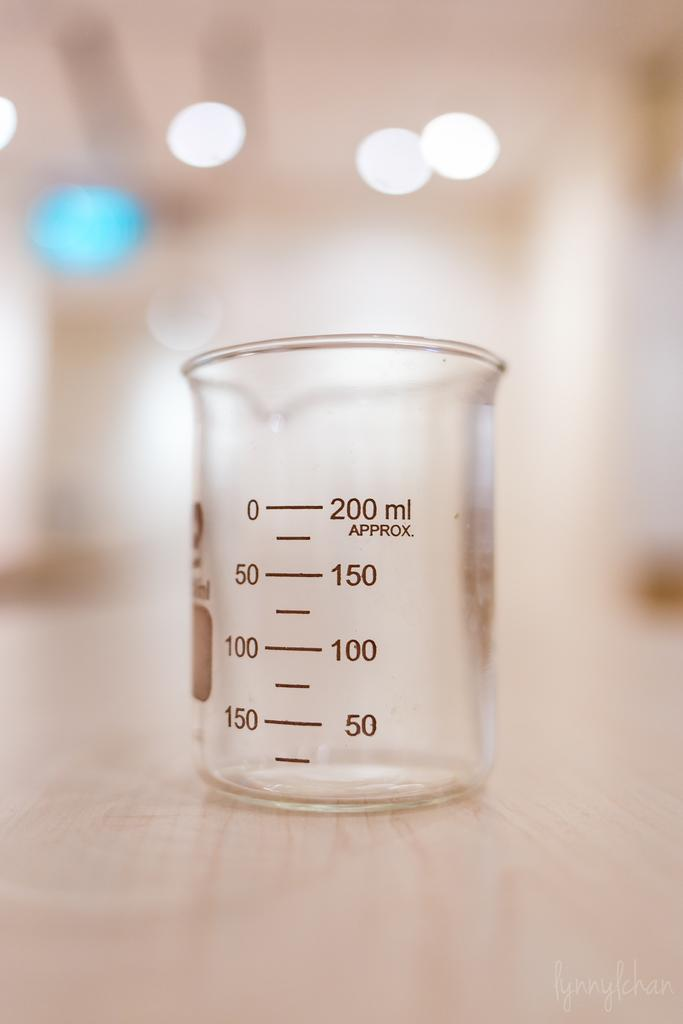<image>
Summarize the visual content of the image. An empty beaker that reads two hundred milliliters approx on the top. 